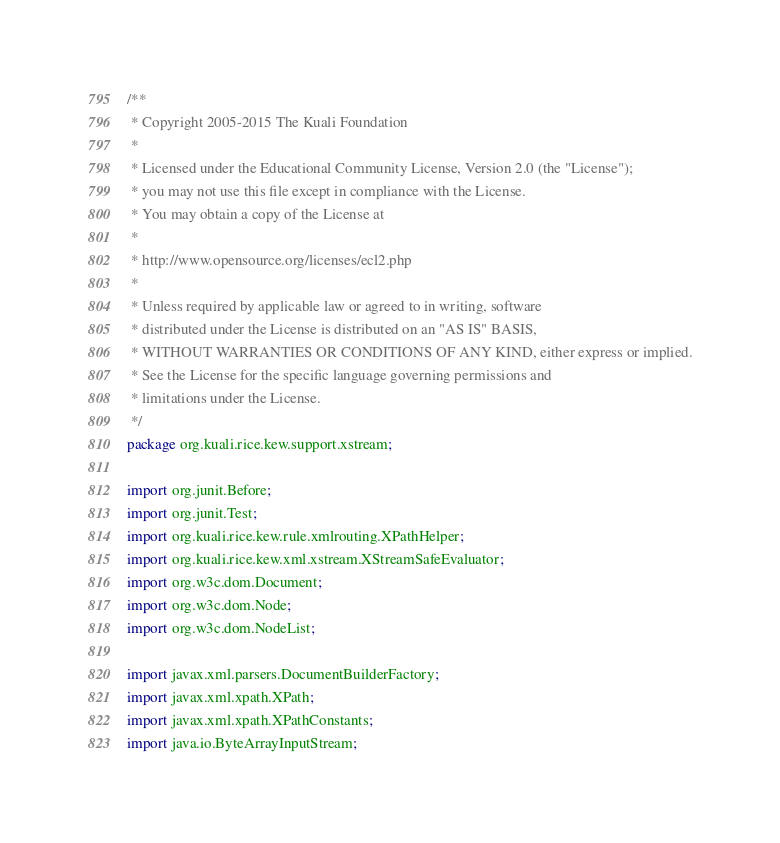Convert code to text. <code><loc_0><loc_0><loc_500><loc_500><_Java_>/**
 * Copyright 2005-2015 The Kuali Foundation
 *
 * Licensed under the Educational Community License, Version 2.0 (the "License");
 * you may not use this file except in compliance with the License.
 * You may obtain a copy of the License at
 *
 * http://www.opensource.org/licenses/ecl2.php
 *
 * Unless required by applicable law or agreed to in writing, software
 * distributed under the License is distributed on an "AS IS" BASIS,
 * WITHOUT WARRANTIES OR CONDITIONS OF ANY KIND, either express or implied.
 * See the License for the specific language governing permissions and
 * limitations under the License.
 */
package org.kuali.rice.kew.support.xstream;

import org.junit.Before;
import org.junit.Test;
import org.kuali.rice.kew.rule.xmlrouting.XPathHelper;
import org.kuali.rice.kew.xml.xstream.XStreamSafeEvaluator;
import org.w3c.dom.Document;
import org.w3c.dom.Node;
import org.w3c.dom.NodeList;

import javax.xml.parsers.DocumentBuilderFactory;
import javax.xml.xpath.XPath;
import javax.xml.xpath.XPathConstants;
import java.io.ByteArrayInputStream;
</code> 